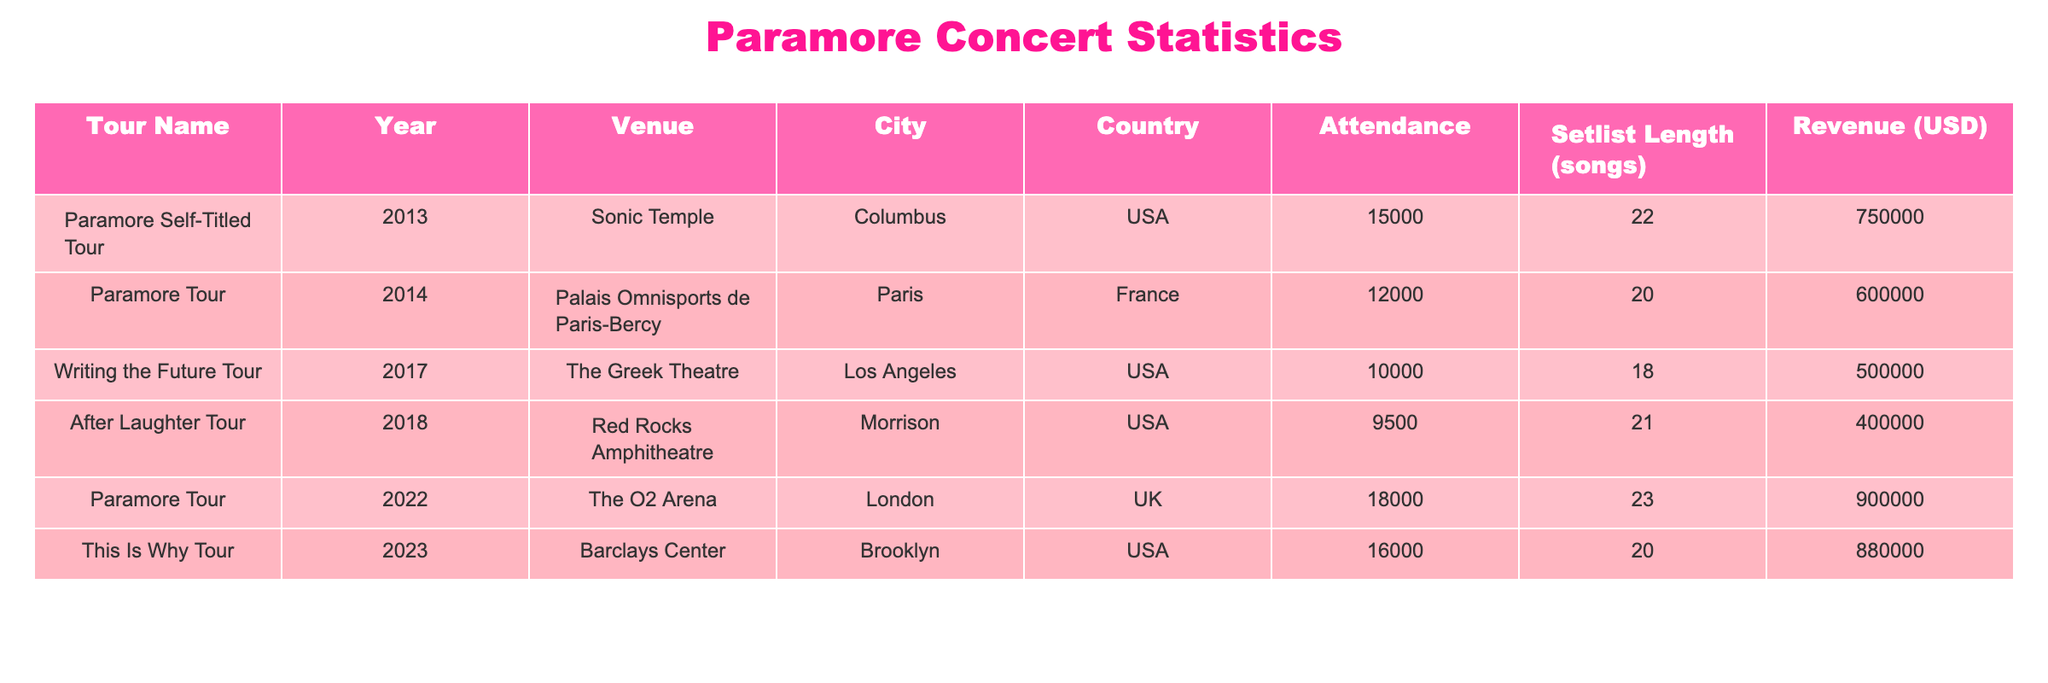What was the highest concert attendance for a Paramore tour in the provided data? The highest concert attendance can be found by looking at the "Attendance" column. The values are 15000, 12000, 10000, 9500, 18000, and 16000. The highest value among these is 18000, which corresponds to the Paramore Tour in 2022.
Answer: 18000 What is the total revenue generated by the "This Is Why Tour"? The revenue for the "This Is Why Tour" can be found directly in the "Revenue (USD)" column. It shows a value of 880000 for this tour.
Answer: 880000 Which tour had the longest setlist and what was the length? The longest setlist can be determined by looking at the "Setlist Length (songs)" column. The values are 22, 20, 18, 21, 23, and 20. The highest number is 23, which belongs to the Paramore Tour in 2022.
Answer: 23 How many concerts had an attendance of over 15000? We check the "Attendance" column for values greater than 15000. The relevant values are 15000 for the Self-Titled Tour, 18000 for the Paramore Tour, and 16000 for the This Is Why Tour. This means there are 2 concerts with attendance over 15000.
Answer: 2 Was the total attendance for the After Laughter Tour less than that for the Writing the Future Tour? The attendance for After Laughter Tour is 9500 and for Writing the Future Tour is 10000. Comparing these two values, 9500 is indeed less than 10000, making the statement true.
Answer: Yes What is the average attendance across all Paramore tours listed? To find the average attendance, we sum the attendance values: 15000 + 12000 + 10000 + 9500 + 18000 + 16000 = 80500. There are 6 tours in total, so the average is 80500 / 6 = 13416.67.
Answer: 13416.67 Did any tour in 2014 generate more revenue than the After Laughter Tour? The revenue for the Paramore Tour in 2014 is 600000 and for the After Laughter Tour is 400000. Since 600000 is more than 400000, the statement is true.
Answer: Yes Which tour generated the least revenue, and what amount was it? The revenues for the tours are 750000, 600000, 500000, 400000, 900000, and 880000. The least revenue is 400000 from the After Laughter Tour.
Answer: 400000 What was the combined attendance for the Paramore Tour in 2014 and the Writing the Future Tour? The attendance for the Paramore Tour in 2014 is 12000 and for the Writing the Future Tour is 10000. Summing these two gives 12000 + 10000 = 22000.
Answer: 22000 